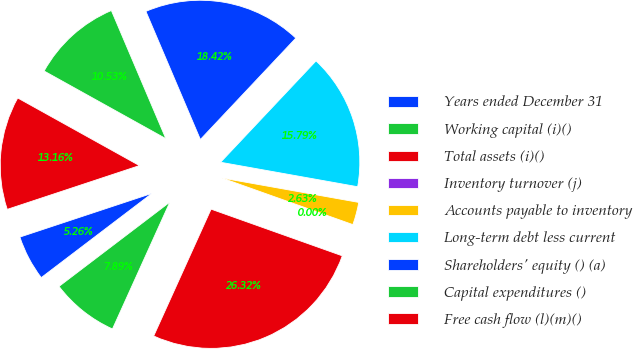Convert chart. <chart><loc_0><loc_0><loc_500><loc_500><pie_chart><fcel>Years ended December 31<fcel>Working capital (i)()<fcel>Total assets (i)()<fcel>Inventory turnover (j)<fcel>Accounts payable to inventory<fcel>Long-term debt less current<fcel>Shareholders' equity () (a)<fcel>Capital expenditures ()<fcel>Free cash flow (l)(m)()<nl><fcel>5.26%<fcel>7.89%<fcel>26.32%<fcel>0.0%<fcel>2.63%<fcel>15.79%<fcel>18.42%<fcel>10.53%<fcel>13.16%<nl></chart> 